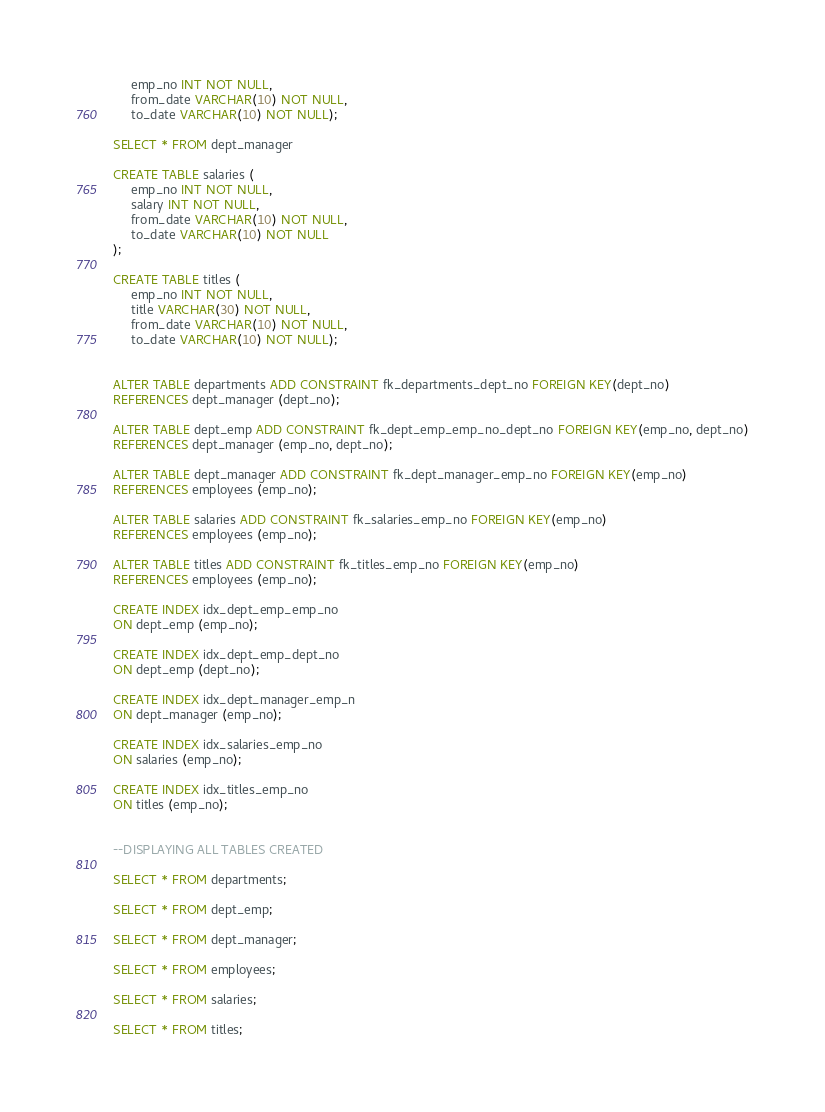Convert code to text. <code><loc_0><loc_0><loc_500><loc_500><_SQL_>     emp_no INT NOT NULL,
     from_date VARCHAR(10) NOT NULL,
     to_date VARCHAR(10) NOT NULL);
	 
SELECT * FROM dept_manager

CREATE TABLE salaries (
     emp_no INT NOT NULL,
     salary INT NOT NULL,
     from_date VARCHAR(10) NOT NULL,
     to_date VARCHAR(10) NOT NULL
);

CREATE TABLE titles (
     emp_no INT NOT NULL,
     title VARCHAR(30) NOT NULL,
     from_date VARCHAR(10) NOT NULL,
     to_date VARCHAR(10) NOT NULL);
	

ALTER TABLE departments ADD CONSTRAINT fk_departments_dept_no FOREIGN KEY(dept_no)
REFERENCES dept_manager (dept_no);

ALTER TABLE dept_emp ADD CONSTRAINT fk_dept_emp_emp_no_dept_no FOREIGN KEY(emp_no, dept_no)
REFERENCES dept_manager (emp_no, dept_no);

ALTER TABLE dept_manager ADD CONSTRAINT fk_dept_manager_emp_no FOREIGN KEY(emp_no)
REFERENCES employees (emp_no);

ALTER TABLE salaries ADD CONSTRAINT fk_salaries_emp_no FOREIGN KEY(emp_no)
REFERENCES employees (emp_no);

ALTER TABLE titles ADD CONSTRAINT fk_titles_emp_no FOREIGN KEY(emp_no)
REFERENCES employees (emp_no);

CREATE INDEX idx_dept_emp_emp_no
ON dept_emp (emp_no);

CREATE INDEX idx_dept_emp_dept_no
ON dept_emp (dept_no);

CREATE INDEX idx_dept_manager_emp_n
ON dept_manager (emp_no);

CREATE INDEX idx_salaries_emp_no
ON salaries (emp_no);

CREATE INDEX idx_titles_emp_no
ON titles (emp_no);


--DISPLAYING ALL TABLES CREATED

SELECT * FROM departments;

SELECT * FROM dept_emp;

SELECT * FROM dept_manager;

SELECT * FROM employees;

SELECT * FROM salaries;

SELECT * FROM titles;



</code> 